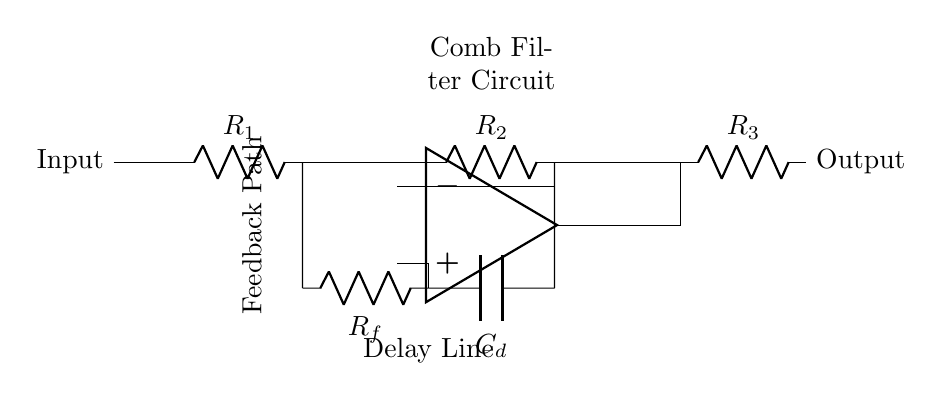What type of circuit is represented? The circuit is a comb filter circuit, visibly indicated by the configuration of resistors and the delay line. This specific combination of components is categorized as a filter due to its ability to modify the frequency response.
Answer: Comb filter circuit What is the role of the op-amp in this circuit? The op-amp (operational amplifier) serves to amplify the difference between the input signals from the delay line and the feedback path. This amplification enhances the filtering characteristics of the circuit.
Answer: Amplification How many resistors are in this circuit? There are three resistors labeled R1, R2, and R3 in the circuit diagram, as seen from their representation along the main signal path.
Answer: Three What does the capacitor C_d do in this circuit? The capacitor C_d is part of the delay line, which helps create the time lag needed to form the comb filter effect. It works in conjunction with the resistor R_f to produce phase shifts in the signal.
Answer: Creates delay What is the feedback path in this circuit? The feedback path is formed by the connection that routes the output of the op-amp back to the input of the delay line. This is essential for generating the comb filter effect by determining the filter's resonance and frequency response.
Answer: Connection to delay line What would happen if the resistance R_f were increased? Increasing R_f would lead to greater feedback, altering the filter's frequency response, generally resulting in a sharper or more pronounced comb filter effect, which emphasizes specific frequencies.
Answer: Sharper filtering effect 